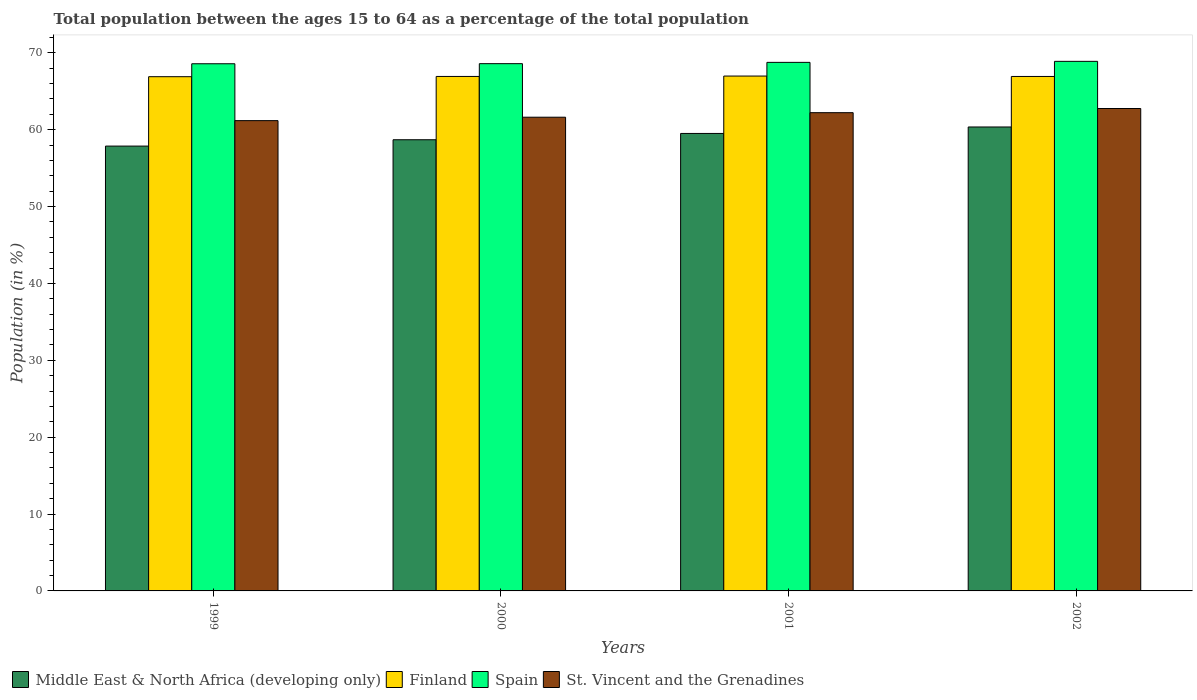Are the number of bars per tick equal to the number of legend labels?
Your answer should be very brief. Yes. Are the number of bars on each tick of the X-axis equal?
Your answer should be compact. Yes. How many bars are there on the 3rd tick from the left?
Provide a short and direct response. 4. How many bars are there on the 2nd tick from the right?
Your answer should be compact. 4. In how many cases, is the number of bars for a given year not equal to the number of legend labels?
Keep it short and to the point. 0. What is the percentage of the population ages 15 to 64 in St. Vincent and the Grenadines in 2000?
Offer a terse response. 61.62. Across all years, what is the maximum percentage of the population ages 15 to 64 in Middle East & North Africa (developing only)?
Offer a terse response. 60.35. Across all years, what is the minimum percentage of the population ages 15 to 64 in Spain?
Your answer should be very brief. 68.58. What is the total percentage of the population ages 15 to 64 in St. Vincent and the Grenadines in the graph?
Offer a terse response. 247.78. What is the difference between the percentage of the population ages 15 to 64 in Middle East & North Africa (developing only) in 1999 and that in 2000?
Your answer should be very brief. -0.82. What is the difference between the percentage of the population ages 15 to 64 in St. Vincent and the Grenadines in 2002 and the percentage of the population ages 15 to 64 in Middle East & North Africa (developing only) in 1999?
Your response must be concise. 4.89. What is the average percentage of the population ages 15 to 64 in St. Vincent and the Grenadines per year?
Make the answer very short. 61.94. In the year 1999, what is the difference between the percentage of the population ages 15 to 64 in Middle East & North Africa (developing only) and percentage of the population ages 15 to 64 in Spain?
Your answer should be compact. -10.71. What is the ratio of the percentage of the population ages 15 to 64 in Finland in 2001 to that in 2002?
Provide a short and direct response. 1. What is the difference between the highest and the second highest percentage of the population ages 15 to 64 in Spain?
Make the answer very short. 0.13. What is the difference between the highest and the lowest percentage of the population ages 15 to 64 in St. Vincent and the Grenadines?
Keep it short and to the point. 1.58. In how many years, is the percentage of the population ages 15 to 64 in Finland greater than the average percentage of the population ages 15 to 64 in Finland taken over all years?
Provide a succinct answer. 1. Is it the case that in every year, the sum of the percentage of the population ages 15 to 64 in Middle East & North Africa (developing only) and percentage of the population ages 15 to 64 in Spain is greater than the sum of percentage of the population ages 15 to 64 in St. Vincent and the Grenadines and percentage of the population ages 15 to 64 in Finland?
Provide a succinct answer. No. What does the 1st bar from the left in 2001 represents?
Offer a very short reply. Middle East & North Africa (developing only). What does the 1st bar from the right in 2001 represents?
Provide a short and direct response. St. Vincent and the Grenadines. Are all the bars in the graph horizontal?
Make the answer very short. No. How many years are there in the graph?
Offer a terse response. 4. Are the values on the major ticks of Y-axis written in scientific E-notation?
Make the answer very short. No. Does the graph contain any zero values?
Your answer should be very brief. No. Where does the legend appear in the graph?
Make the answer very short. Bottom left. How many legend labels are there?
Provide a short and direct response. 4. What is the title of the graph?
Your answer should be very brief. Total population between the ages 15 to 64 as a percentage of the total population. Does "India" appear as one of the legend labels in the graph?
Keep it short and to the point. No. What is the label or title of the Y-axis?
Your response must be concise. Population (in %). What is the Population (in %) in Middle East & North Africa (developing only) in 1999?
Make the answer very short. 57.87. What is the Population (in %) in Finland in 1999?
Keep it short and to the point. 66.9. What is the Population (in %) of Spain in 1999?
Make the answer very short. 68.58. What is the Population (in %) in St. Vincent and the Grenadines in 1999?
Ensure brevity in your answer.  61.18. What is the Population (in %) of Middle East & North Africa (developing only) in 2000?
Give a very brief answer. 58.69. What is the Population (in %) in Finland in 2000?
Offer a terse response. 66.93. What is the Population (in %) of Spain in 2000?
Ensure brevity in your answer.  68.59. What is the Population (in %) in St. Vincent and the Grenadines in 2000?
Your response must be concise. 61.62. What is the Population (in %) in Middle East & North Africa (developing only) in 2001?
Your answer should be compact. 59.51. What is the Population (in %) of Finland in 2001?
Make the answer very short. 66.98. What is the Population (in %) of Spain in 2001?
Give a very brief answer. 68.76. What is the Population (in %) in St. Vincent and the Grenadines in 2001?
Make the answer very short. 62.22. What is the Population (in %) in Middle East & North Africa (developing only) in 2002?
Ensure brevity in your answer.  60.35. What is the Population (in %) of Finland in 2002?
Give a very brief answer. 66.93. What is the Population (in %) in Spain in 2002?
Make the answer very short. 68.89. What is the Population (in %) of St. Vincent and the Grenadines in 2002?
Provide a succinct answer. 62.76. Across all years, what is the maximum Population (in %) in Middle East & North Africa (developing only)?
Provide a short and direct response. 60.35. Across all years, what is the maximum Population (in %) in Finland?
Keep it short and to the point. 66.98. Across all years, what is the maximum Population (in %) of Spain?
Provide a succinct answer. 68.89. Across all years, what is the maximum Population (in %) in St. Vincent and the Grenadines?
Provide a short and direct response. 62.76. Across all years, what is the minimum Population (in %) in Middle East & North Africa (developing only)?
Give a very brief answer. 57.87. Across all years, what is the minimum Population (in %) in Finland?
Provide a succinct answer. 66.9. Across all years, what is the minimum Population (in %) of Spain?
Give a very brief answer. 68.58. Across all years, what is the minimum Population (in %) of St. Vincent and the Grenadines?
Provide a short and direct response. 61.18. What is the total Population (in %) of Middle East & North Africa (developing only) in the graph?
Keep it short and to the point. 236.43. What is the total Population (in %) of Finland in the graph?
Offer a terse response. 267.73. What is the total Population (in %) in Spain in the graph?
Offer a very short reply. 274.82. What is the total Population (in %) in St. Vincent and the Grenadines in the graph?
Make the answer very short. 247.78. What is the difference between the Population (in %) of Middle East & North Africa (developing only) in 1999 and that in 2000?
Keep it short and to the point. -0.82. What is the difference between the Population (in %) of Finland in 1999 and that in 2000?
Your response must be concise. -0.03. What is the difference between the Population (in %) of Spain in 1999 and that in 2000?
Offer a terse response. -0.01. What is the difference between the Population (in %) of St. Vincent and the Grenadines in 1999 and that in 2000?
Make the answer very short. -0.44. What is the difference between the Population (in %) of Middle East & North Africa (developing only) in 1999 and that in 2001?
Your answer should be compact. -1.64. What is the difference between the Population (in %) in Finland in 1999 and that in 2001?
Provide a short and direct response. -0.08. What is the difference between the Population (in %) in Spain in 1999 and that in 2001?
Give a very brief answer. -0.18. What is the difference between the Population (in %) of St. Vincent and the Grenadines in 1999 and that in 2001?
Provide a succinct answer. -1.04. What is the difference between the Population (in %) of Middle East & North Africa (developing only) in 1999 and that in 2002?
Ensure brevity in your answer.  -2.49. What is the difference between the Population (in %) of Finland in 1999 and that in 2002?
Your answer should be very brief. -0.03. What is the difference between the Population (in %) of Spain in 1999 and that in 2002?
Your response must be concise. -0.31. What is the difference between the Population (in %) of St. Vincent and the Grenadines in 1999 and that in 2002?
Ensure brevity in your answer.  -1.58. What is the difference between the Population (in %) of Middle East & North Africa (developing only) in 2000 and that in 2001?
Offer a very short reply. -0.82. What is the difference between the Population (in %) in Finland in 2000 and that in 2001?
Your response must be concise. -0.05. What is the difference between the Population (in %) of Spain in 2000 and that in 2001?
Ensure brevity in your answer.  -0.17. What is the difference between the Population (in %) of St. Vincent and the Grenadines in 2000 and that in 2001?
Keep it short and to the point. -0.59. What is the difference between the Population (in %) in Middle East & North Africa (developing only) in 2000 and that in 2002?
Your answer should be compact. -1.66. What is the difference between the Population (in %) of Finland in 2000 and that in 2002?
Offer a terse response. 0. What is the difference between the Population (in %) in Spain in 2000 and that in 2002?
Offer a terse response. -0.3. What is the difference between the Population (in %) of St. Vincent and the Grenadines in 2000 and that in 2002?
Provide a short and direct response. -1.13. What is the difference between the Population (in %) in Middle East & North Africa (developing only) in 2001 and that in 2002?
Give a very brief answer. -0.84. What is the difference between the Population (in %) in Finland in 2001 and that in 2002?
Offer a very short reply. 0.05. What is the difference between the Population (in %) in Spain in 2001 and that in 2002?
Provide a succinct answer. -0.13. What is the difference between the Population (in %) in St. Vincent and the Grenadines in 2001 and that in 2002?
Ensure brevity in your answer.  -0.54. What is the difference between the Population (in %) of Middle East & North Africa (developing only) in 1999 and the Population (in %) of Finland in 2000?
Your answer should be compact. -9.06. What is the difference between the Population (in %) of Middle East & North Africa (developing only) in 1999 and the Population (in %) of Spain in 2000?
Offer a very short reply. -10.72. What is the difference between the Population (in %) of Middle East & North Africa (developing only) in 1999 and the Population (in %) of St. Vincent and the Grenadines in 2000?
Offer a very short reply. -3.76. What is the difference between the Population (in %) in Finland in 1999 and the Population (in %) in Spain in 2000?
Keep it short and to the point. -1.7. What is the difference between the Population (in %) of Finland in 1999 and the Population (in %) of St. Vincent and the Grenadines in 2000?
Your answer should be compact. 5.27. What is the difference between the Population (in %) in Spain in 1999 and the Population (in %) in St. Vincent and the Grenadines in 2000?
Provide a short and direct response. 6.96. What is the difference between the Population (in %) in Middle East & North Africa (developing only) in 1999 and the Population (in %) in Finland in 2001?
Offer a very short reply. -9.11. What is the difference between the Population (in %) of Middle East & North Africa (developing only) in 1999 and the Population (in %) of Spain in 2001?
Keep it short and to the point. -10.89. What is the difference between the Population (in %) in Middle East & North Africa (developing only) in 1999 and the Population (in %) in St. Vincent and the Grenadines in 2001?
Your answer should be very brief. -4.35. What is the difference between the Population (in %) of Finland in 1999 and the Population (in %) of Spain in 2001?
Make the answer very short. -1.86. What is the difference between the Population (in %) of Finland in 1999 and the Population (in %) of St. Vincent and the Grenadines in 2001?
Your answer should be very brief. 4.68. What is the difference between the Population (in %) of Spain in 1999 and the Population (in %) of St. Vincent and the Grenadines in 2001?
Offer a very short reply. 6.36. What is the difference between the Population (in %) in Middle East & North Africa (developing only) in 1999 and the Population (in %) in Finland in 2002?
Provide a succinct answer. -9.06. What is the difference between the Population (in %) of Middle East & North Africa (developing only) in 1999 and the Population (in %) of Spain in 2002?
Your response must be concise. -11.02. What is the difference between the Population (in %) in Middle East & North Africa (developing only) in 1999 and the Population (in %) in St. Vincent and the Grenadines in 2002?
Your answer should be very brief. -4.89. What is the difference between the Population (in %) in Finland in 1999 and the Population (in %) in Spain in 2002?
Provide a short and direct response. -2. What is the difference between the Population (in %) of Finland in 1999 and the Population (in %) of St. Vincent and the Grenadines in 2002?
Provide a succinct answer. 4.14. What is the difference between the Population (in %) of Spain in 1999 and the Population (in %) of St. Vincent and the Grenadines in 2002?
Provide a succinct answer. 5.82. What is the difference between the Population (in %) of Middle East & North Africa (developing only) in 2000 and the Population (in %) of Finland in 2001?
Keep it short and to the point. -8.29. What is the difference between the Population (in %) in Middle East & North Africa (developing only) in 2000 and the Population (in %) in Spain in 2001?
Your answer should be compact. -10.07. What is the difference between the Population (in %) in Middle East & North Africa (developing only) in 2000 and the Population (in %) in St. Vincent and the Grenadines in 2001?
Keep it short and to the point. -3.52. What is the difference between the Population (in %) in Finland in 2000 and the Population (in %) in Spain in 2001?
Offer a terse response. -1.83. What is the difference between the Population (in %) in Finland in 2000 and the Population (in %) in St. Vincent and the Grenadines in 2001?
Give a very brief answer. 4.71. What is the difference between the Population (in %) of Spain in 2000 and the Population (in %) of St. Vincent and the Grenadines in 2001?
Make the answer very short. 6.38. What is the difference between the Population (in %) in Middle East & North Africa (developing only) in 2000 and the Population (in %) in Finland in 2002?
Make the answer very short. -8.23. What is the difference between the Population (in %) of Middle East & North Africa (developing only) in 2000 and the Population (in %) of Spain in 2002?
Offer a terse response. -10.2. What is the difference between the Population (in %) of Middle East & North Africa (developing only) in 2000 and the Population (in %) of St. Vincent and the Grenadines in 2002?
Your answer should be compact. -4.06. What is the difference between the Population (in %) of Finland in 2000 and the Population (in %) of Spain in 2002?
Give a very brief answer. -1.96. What is the difference between the Population (in %) of Finland in 2000 and the Population (in %) of St. Vincent and the Grenadines in 2002?
Provide a short and direct response. 4.17. What is the difference between the Population (in %) of Spain in 2000 and the Population (in %) of St. Vincent and the Grenadines in 2002?
Give a very brief answer. 5.83. What is the difference between the Population (in %) of Middle East & North Africa (developing only) in 2001 and the Population (in %) of Finland in 2002?
Give a very brief answer. -7.41. What is the difference between the Population (in %) in Middle East & North Africa (developing only) in 2001 and the Population (in %) in Spain in 2002?
Give a very brief answer. -9.38. What is the difference between the Population (in %) of Middle East & North Africa (developing only) in 2001 and the Population (in %) of St. Vincent and the Grenadines in 2002?
Provide a succinct answer. -3.24. What is the difference between the Population (in %) in Finland in 2001 and the Population (in %) in Spain in 2002?
Your response must be concise. -1.91. What is the difference between the Population (in %) of Finland in 2001 and the Population (in %) of St. Vincent and the Grenadines in 2002?
Provide a succinct answer. 4.22. What is the difference between the Population (in %) of Spain in 2001 and the Population (in %) of St. Vincent and the Grenadines in 2002?
Offer a terse response. 6. What is the average Population (in %) of Middle East & North Africa (developing only) per year?
Offer a terse response. 59.11. What is the average Population (in %) in Finland per year?
Provide a short and direct response. 66.93. What is the average Population (in %) in Spain per year?
Keep it short and to the point. 68.71. What is the average Population (in %) in St. Vincent and the Grenadines per year?
Provide a short and direct response. 61.94. In the year 1999, what is the difference between the Population (in %) of Middle East & North Africa (developing only) and Population (in %) of Finland?
Make the answer very short. -9.03. In the year 1999, what is the difference between the Population (in %) of Middle East & North Africa (developing only) and Population (in %) of Spain?
Offer a very short reply. -10.71. In the year 1999, what is the difference between the Population (in %) of Middle East & North Africa (developing only) and Population (in %) of St. Vincent and the Grenadines?
Your answer should be compact. -3.31. In the year 1999, what is the difference between the Population (in %) of Finland and Population (in %) of Spain?
Ensure brevity in your answer.  -1.68. In the year 1999, what is the difference between the Population (in %) of Finland and Population (in %) of St. Vincent and the Grenadines?
Make the answer very short. 5.72. In the year 1999, what is the difference between the Population (in %) of Spain and Population (in %) of St. Vincent and the Grenadines?
Keep it short and to the point. 7.4. In the year 2000, what is the difference between the Population (in %) in Middle East & North Africa (developing only) and Population (in %) in Finland?
Ensure brevity in your answer.  -8.24. In the year 2000, what is the difference between the Population (in %) of Middle East & North Africa (developing only) and Population (in %) of Spain?
Your response must be concise. -9.9. In the year 2000, what is the difference between the Population (in %) of Middle East & North Africa (developing only) and Population (in %) of St. Vincent and the Grenadines?
Provide a short and direct response. -2.93. In the year 2000, what is the difference between the Population (in %) of Finland and Population (in %) of Spain?
Offer a terse response. -1.66. In the year 2000, what is the difference between the Population (in %) of Finland and Population (in %) of St. Vincent and the Grenadines?
Offer a very short reply. 5.3. In the year 2000, what is the difference between the Population (in %) of Spain and Population (in %) of St. Vincent and the Grenadines?
Your response must be concise. 6.97. In the year 2001, what is the difference between the Population (in %) of Middle East & North Africa (developing only) and Population (in %) of Finland?
Provide a succinct answer. -7.47. In the year 2001, what is the difference between the Population (in %) of Middle East & North Africa (developing only) and Population (in %) of Spain?
Provide a short and direct response. -9.25. In the year 2001, what is the difference between the Population (in %) of Middle East & North Africa (developing only) and Population (in %) of St. Vincent and the Grenadines?
Your answer should be very brief. -2.7. In the year 2001, what is the difference between the Population (in %) in Finland and Population (in %) in Spain?
Provide a short and direct response. -1.78. In the year 2001, what is the difference between the Population (in %) in Finland and Population (in %) in St. Vincent and the Grenadines?
Keep it short and to the point. 4.76. In the year 2001, what is the difference between the Population (in %) in Spain and Population (in %) in St. Vincent and the Grenadines?
Your response must be concise. 6.54. In the year 2002, what is the difference between the Population (in %) of Middle East & North Africa (developing only) and Population (in %) of Finland?
Keep it short and to the point. -6.57. In the year 2002, what is the difference between the Population (in %) in Middle East & North Africa (developing only) and Population (in %) in Spain?
Give a very brief answer. -8.54. In the year 2002, what is the difference between the Population (in %) in Middle East & North Africa (developing only) and Population (in %) in St. Vincent and the Grenadines?
Make the answer very short. -2.4. In the year 2002, what is the difference between the Population (in %) in Finland and Population (in %) in Spain?
Your answer should be compact. -1.96. In the year 2002, what is the difference between the Population (in %) in Finland and Population (in %) in St. Vincent and the Grenadines?
Keep it short and to the point. 4.17. In the year 2002, what is the difference between the Population (in %) in Spain and Population (in %) in St. Vincent and the Grenadines?
Provide a short and direct response. 6.13. What is the ratio of the Population (in %) in Middle East & North Africa (developing only) in 1999 to that in 2000?
Offer a very short reply. 0.99. What is the ratio of the Population (in %) in Spain in 1999 to that in 2000?
Your answer should be compact. 1. What is the ratio of the Population (in %) of St. Vincent and the Grenadines in 1999 to that in 2000?
Your answer should be compact. 0.99. What is the ratio of the Population (in %) of Middle East & North Africa (developing only) in 1999 to that in 2001?
Give a very brief answer. 0.97. What is the ratio of the Population (in %) of St. Vincent and the Grenadines in 1999 to that in 2001?
Ensure brevity in your answer.  0.98. What is the ratio of the Population (in %) in Middle East & North Africa (developing only) in 1999 to that in 2002?
Give a very brief answer. 0.96. What is the ratio of the Population (in %) of Spain in 1999 to that in 2002?
Offer a very short reply. 1. What is the ratio of the Population (in %) in St. Vincent and the Grenadines in 1999 to that in 2002?
Your answer should be compact. 0.97. What is the ratio of the Population (in %) of Middle East & North Africa (developing only) in 2000 to that in 2001?
Your response must be concise. 0.99. What is the ratio of the Population (in %) of Finland in 2000 to that in 2001?
Your response must be concise. 1. What is the ratio of the Population (in %) in Spain in 2000 to that in 2001?
Provide a short and direct response. 1. What is the ratio of the Population (in %) of Middle East & North Africa (developing only) in 2000 to that in 2002?
Offer a very short reply. 0.97. What is the ratio of the Population (in %) in Finland in 2000 to that in 2002?
Provide a succinct answer. 1. What is the ratio of the Population (in %) of St. Vincent and the Grenadines in 2000 to that in 2002?
Keep it short and to the point. 0.98. What is the ratio of the Population (in %) in Middle East & North Africa (developing only) in 2001 to that in 2002?
Keep it short and to the point. 0.99. What is the ratio of the Population (in %) of St. Vincent and the Grenadines in 2001 to that in 2002?
Ensure brevity in your answer.  0.99. What is the difference between the highest and the second highest Population (in %) in Middle East & North Africa (developing only)?
Provide a short and direct response. 0.84. What is the difference between the highest and the second highest Population (in %) in Finland?
Offer a terse response. 0.05. What is the difference between the highest and the second highest Population (in %) in Spain?
Offer a very short reply. 0.13. What is the difference between the highest and the second highest Population (in %) of St. Vincent and the Grenadines?
Keep it short and to the point. 0.54. What is the difference between the highest and the lowest Population (in %) of Middle East & North Africa (developing only)?
Provide a short and direct response. 2.49. What is the difference between the highest and the lowest Population (in %) in Finland?
Provide a short and direct response. 0.08. What is the difference between the highest and the lowest Population (in %) in Spain?
Provide a short and direct response. 0.31. What is the difference between the highest and the lowest Population (in %) of St. Vincent and the Grenadines?
Give a very brief answer. 1.58. 